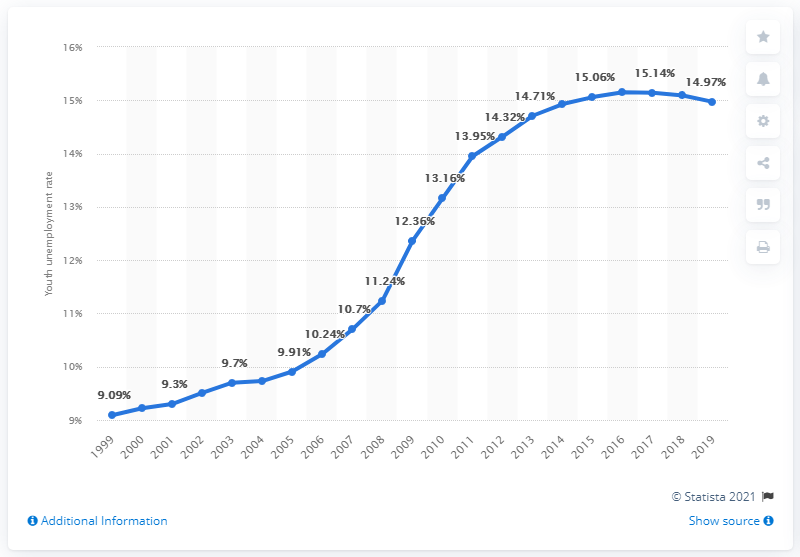List a handful of essential elements in this visual. In 2019, the youth unemployment rate in Fiji was 14.97%. 